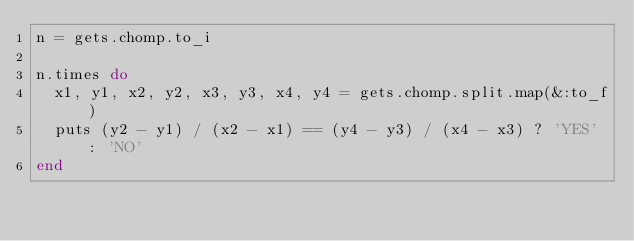<code> <loc_0><loc_0><loc_500><loc_500><_Ruby_>n = gets.chomp.to_i

n.times do
  x1, y1, x2, y2, x3, y3, x4, y4 = gets.chomp.split.map(&:to_f)
  puts (y2 - y1) / (x2 - x1) == (y4 - y3) / (x4 - x3) ? 'YES' : 'NO'
end</code> 